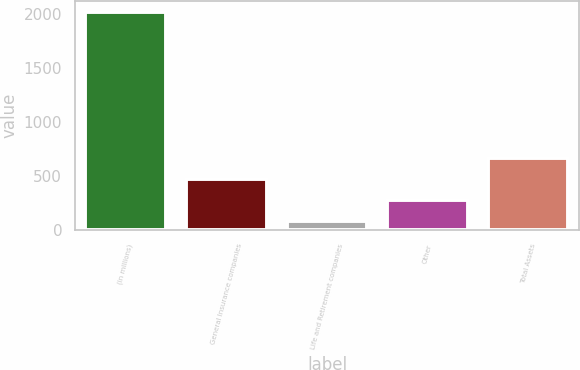Convert chart to OTSL. <chart><loc_0><loc_0><loc_500><loc_500><bar_chart><fcel>(in millions)<fcel>General Insurance companies<fcel>Life and Retirement companies<fcel>Other<fcel>Total Assets<nl><fcel>2017<fcel>473.8<fcel>88<fcel>280.9<fcel>666.7<nl></chart> 